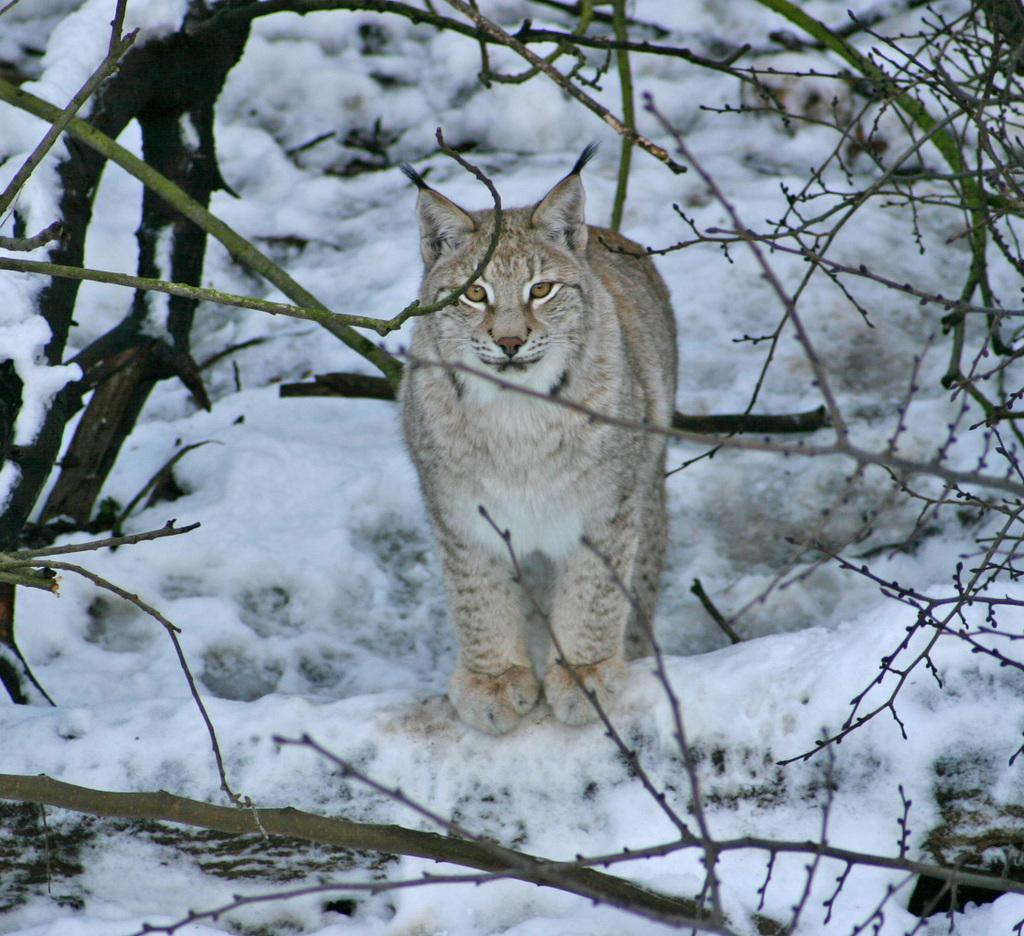What type of animal is in the image? There is a cat in the image. What surface is the cat standing on? The cat is standing on the snow. What type of vegetation can be seen in the image? There are tree stems in the image. What is the weather like in the image? The snow visible in the image suggests a cold, wintry weather. What type of thrill can be seen on the side of the cat in the image? There is no indication of any thrill or excitement in the image; it simply shows a cat standing on the snow. 